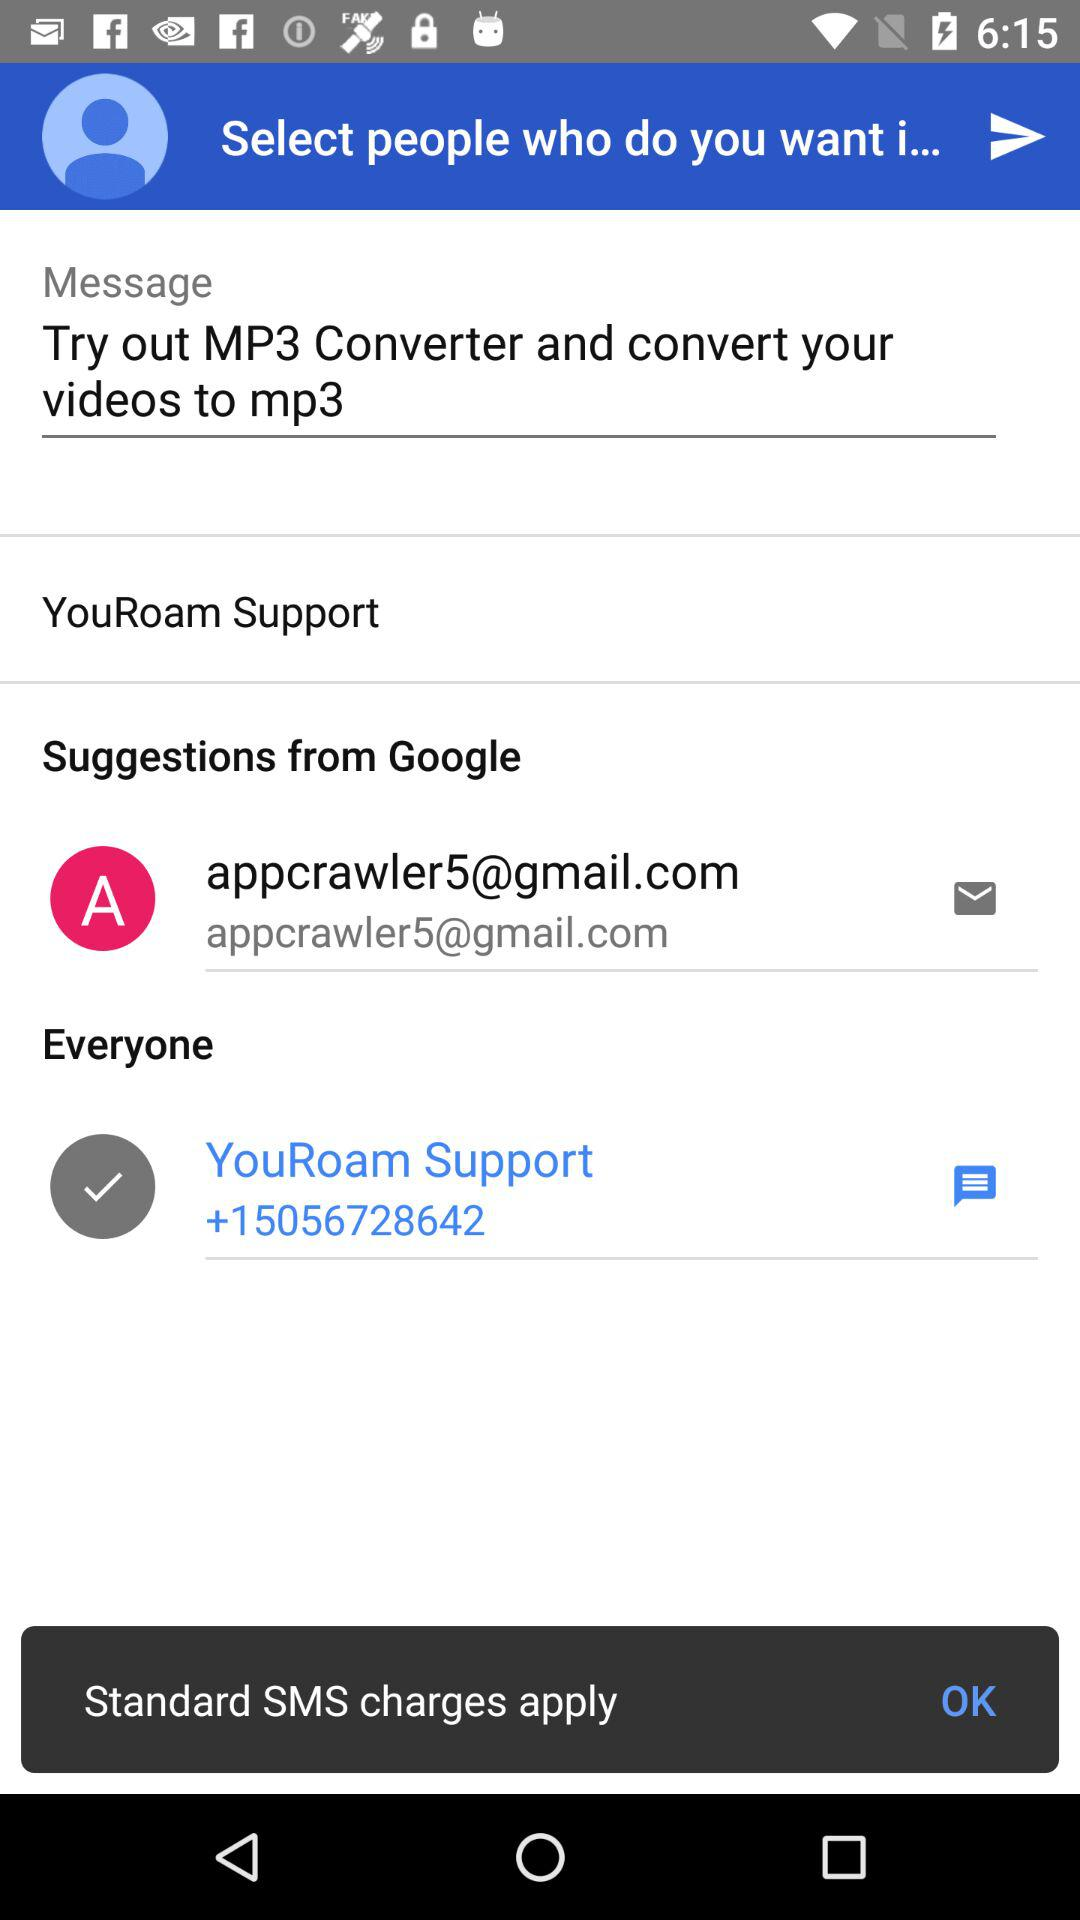What is the email address? The email address is appcrawler5@gmail.com. 